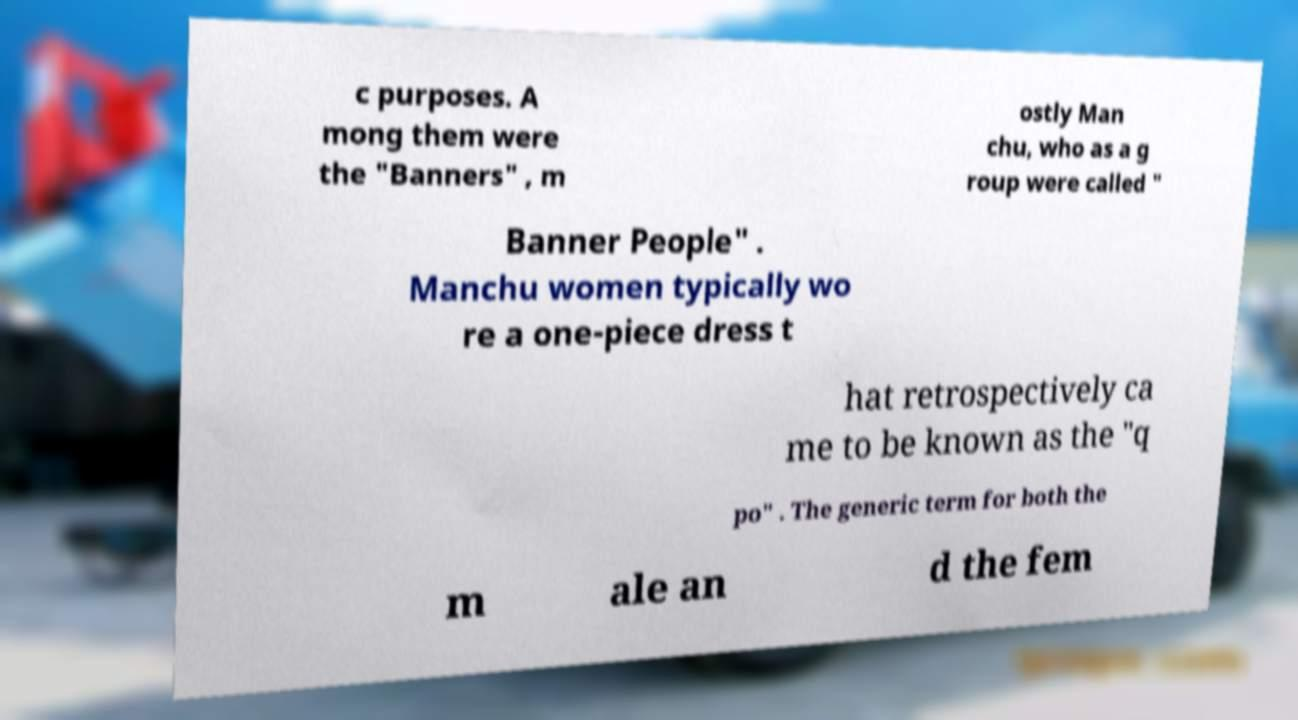Please read and relay the text visible in this image. What does it say? c purposes. A mong them were the "Banners" , m ostly Man chu, who as a g roup were called " Banner People" . Manchu women typically wo re a one-piece dress t hat retrospectively ca me to be known as the "q po" . The generic term for both the m ale an d the fem 